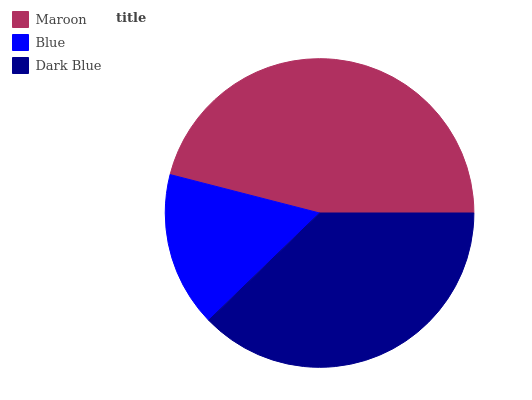Is Blue the minimum?
Answer yes or no. Yes. Is Maroon the maximum?
Answer yes or no. Yes. Is Dark Blue the minimum?
Answer yes or no. No. Is Dark Blue the maximum?
Answer yes or no. No. Is Dark Blue greater than Blue?
Answer yes or no. Yes. Is Blue less than Dark Blue?
Answer yes or no. Yes. Is Blue greater than Dark Blue?
Answer yes or no. No. Is Dark Blue less than Blue?
Answer yes or no. No. Is Dark Blue the high median?
Answer yes or no. Yes. Is Dark Blue the low median?
Answer yes or no. Yes. Is Maroon the high median?
Answer yes or no. No. Is Blue the low median?
Answer yes or no. No. 